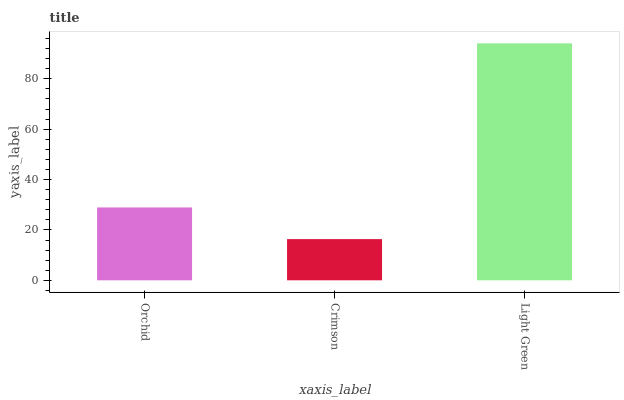Is Crimson the minimum?
Answer yes or no. Yes. Is Light Green the maximum?
Answer yes or no. Yes. Is Light Green the minimum?
Answer yes or no. No. Is Crimson the maximum?
Answer yes or no. No. Is Light Green greater than Crimson?
Answer yes or no. Yes. Is Crimson less than Light Green?
Answer yes or no. Yes. Is Crimson greater than Light Green?
Answer yes or no. No. Is Light Green less than Crimson?
Answer yes or no. No. Is Orchid the high median?
Answer yes or no. Yes. Is Orchid the low median?
Answer yes or no. Yes. Is Crimson the high median?
Answer yes or no. No. Is Light Green the low median?
Answer yes or no. No. 